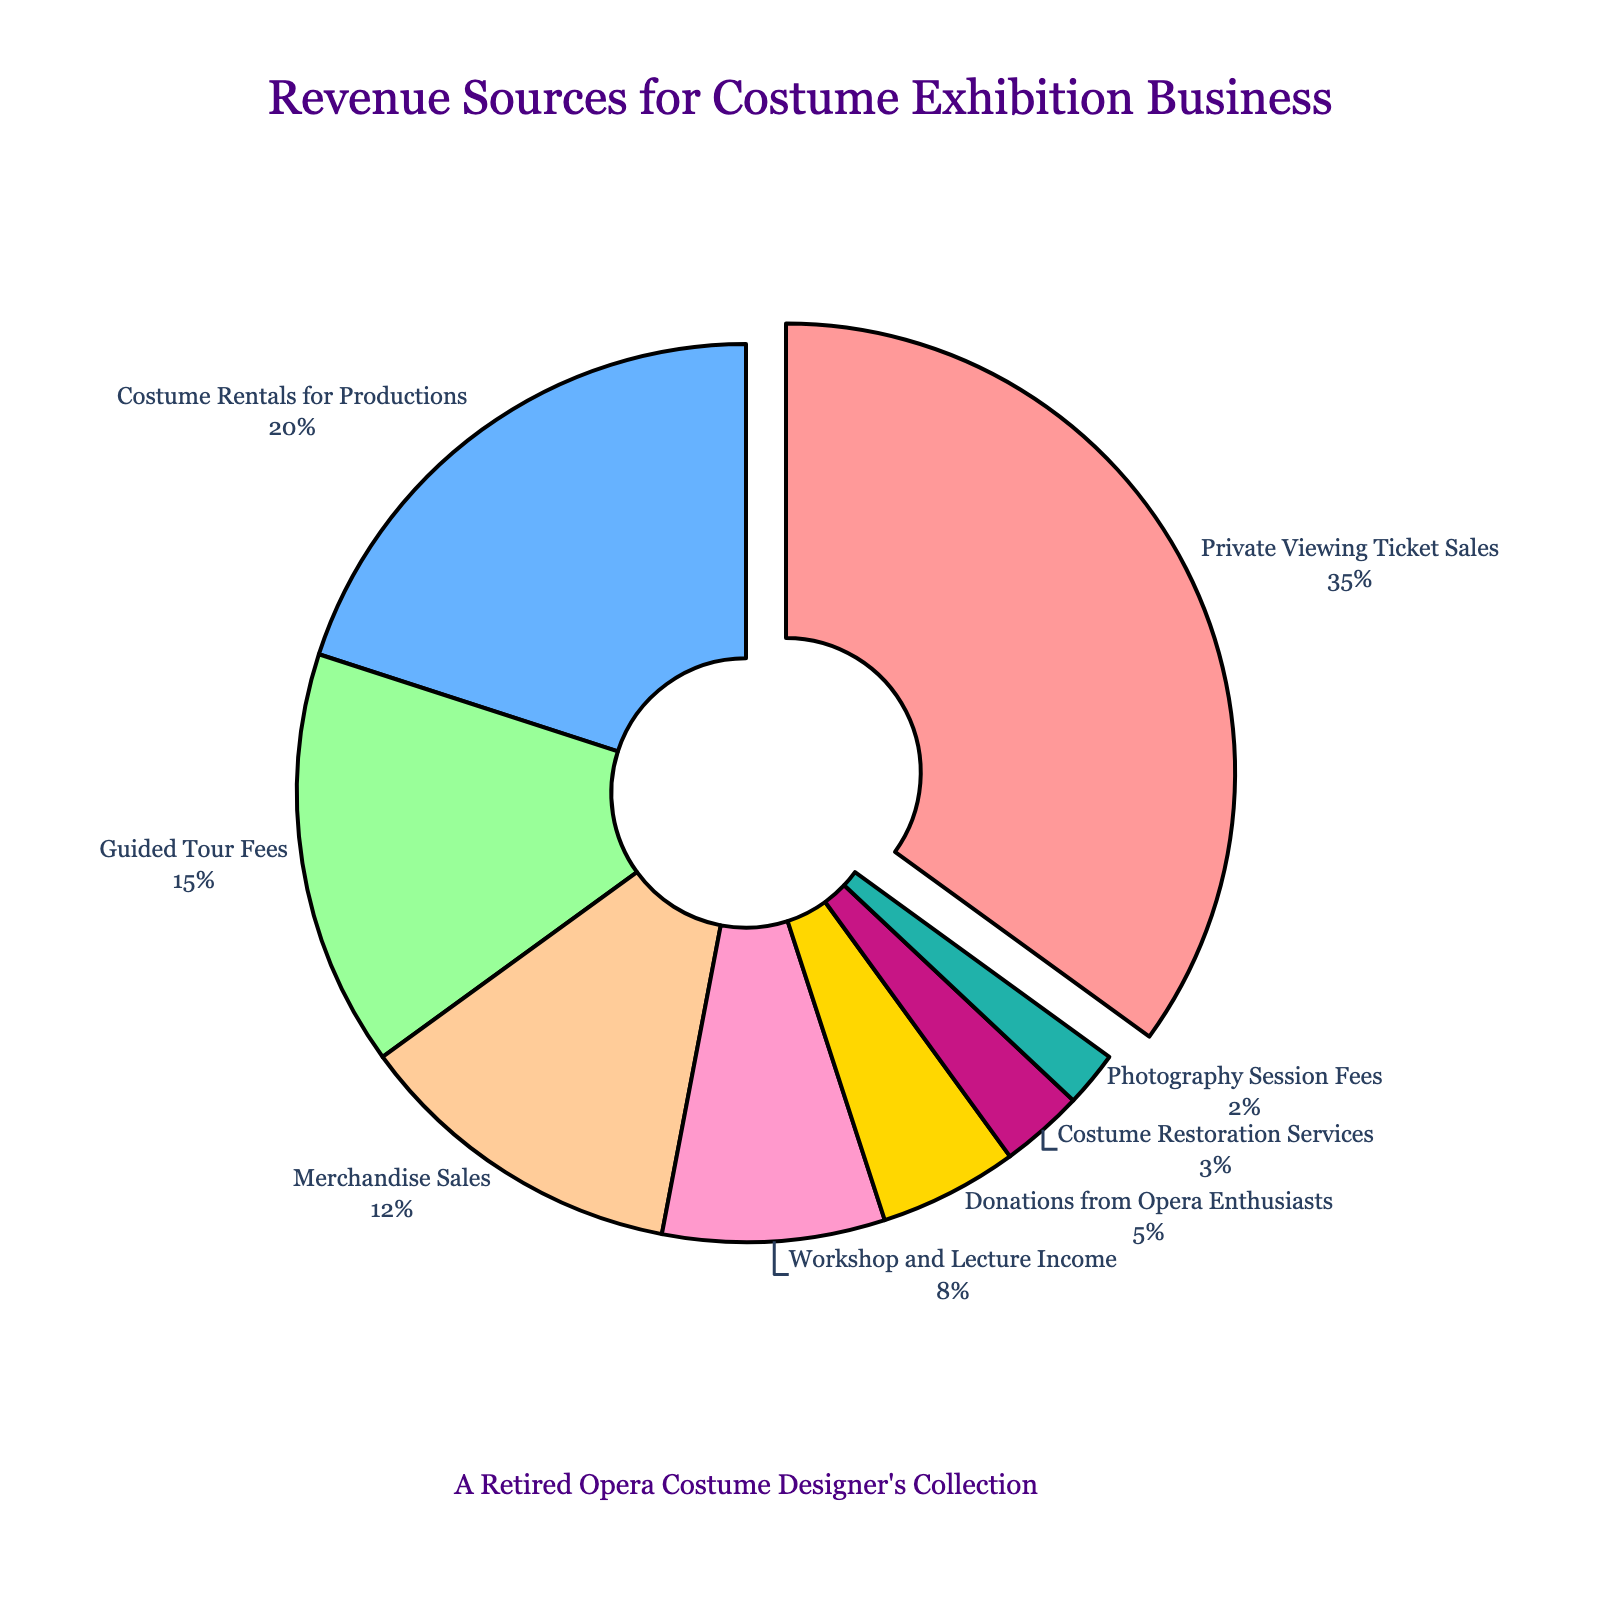What's the largest source of revenue? The largest slice of the pie chart represents Private Viewing Ticket Sales. Its size and the fact that it is slightly pulled out indicate it is the largest source.
Answer: Private Viewing Ticket Sales How much revenue do Private Viewing Ticket Sales and Costume Rentals for Productions contribute together? Add the percentages of Private Viewing Ticket Sales (35%) and Costume Rentals for Productions (20%). So, 35 + 20 = 55%.
Answer: 55% Which revenue source contributes the least to the overall income? The smallest slice of the pie chart represents Photography Session Fees, indicating it is the least contributing source.
Answer: Photography Session Fees Which sources contribute more than 10% each? Identify the slices whose percentages are larger than 10%. They are Private Viewing Ticket Sales (35%), Costume Rentals for Productions (20%), and Guided Tour Fees (15%), and Merchandise Sales (12%).
Answer: Private Viewing Ticket Sales, Costume Rentals for Productions, Guided Tour Fees, Merchandise Sales What's the total percentage of revenue from all sources that contribute exactly 8% or less each? Add percentages of Workshop and Lecture Income (8%), Donations from Opera Enthusiasts (5%), Costume Restoration Services (3%), and Photography Session Fees (2%). So, 8 + 5 + 3 + 2 = 18%.
Answer: 18% Compare the revenue from Guided Tour Fees and Merchandise Sales. Which one is higher? Guided Tour Fees have a percentage of 15%, while Merchandise Sales have 12%. Since 15% > 12%, Guided Tour Fees contribute more than Merchandise Sales.
Answer: Guided Tour Fees How much more does Costume Rentals for Productions contribute compared to Workshop and Lecture Income? Subtract the percentage of Workshop and Lecture Income (8%) from Costume Rentals for Productions (20%). So, 20 - 8 = 12%.
Answer: 12% What is the combined contribution of Costume Restoration Services and Photography Session Fees? Add the percentages of Costume Restoration Services (3%) and Photography Session Fees (2%). So, 3 + 2 = 5%.
Answer: 5% Identify the source with a percentage closest to that of Merchandise Sales. Compare other percentages to Merchandise Sales (12%) and find the closest. Guided Tour Fees at 15% is closest to 12%.
Answer: Guided Tour Fees 